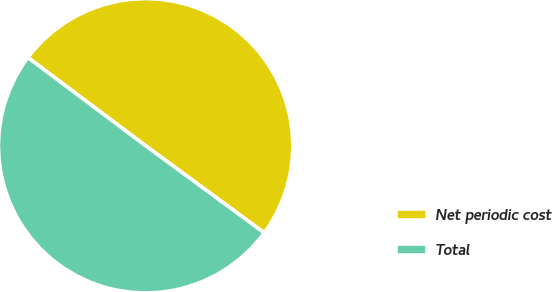<chart> <loc_0><loc_0><loc_500><loc_500><pie_chart><fcel>Net periodic cost<fcel>Total<nl><fcel>49.84%<fcel>50.16%<nl></chart> 